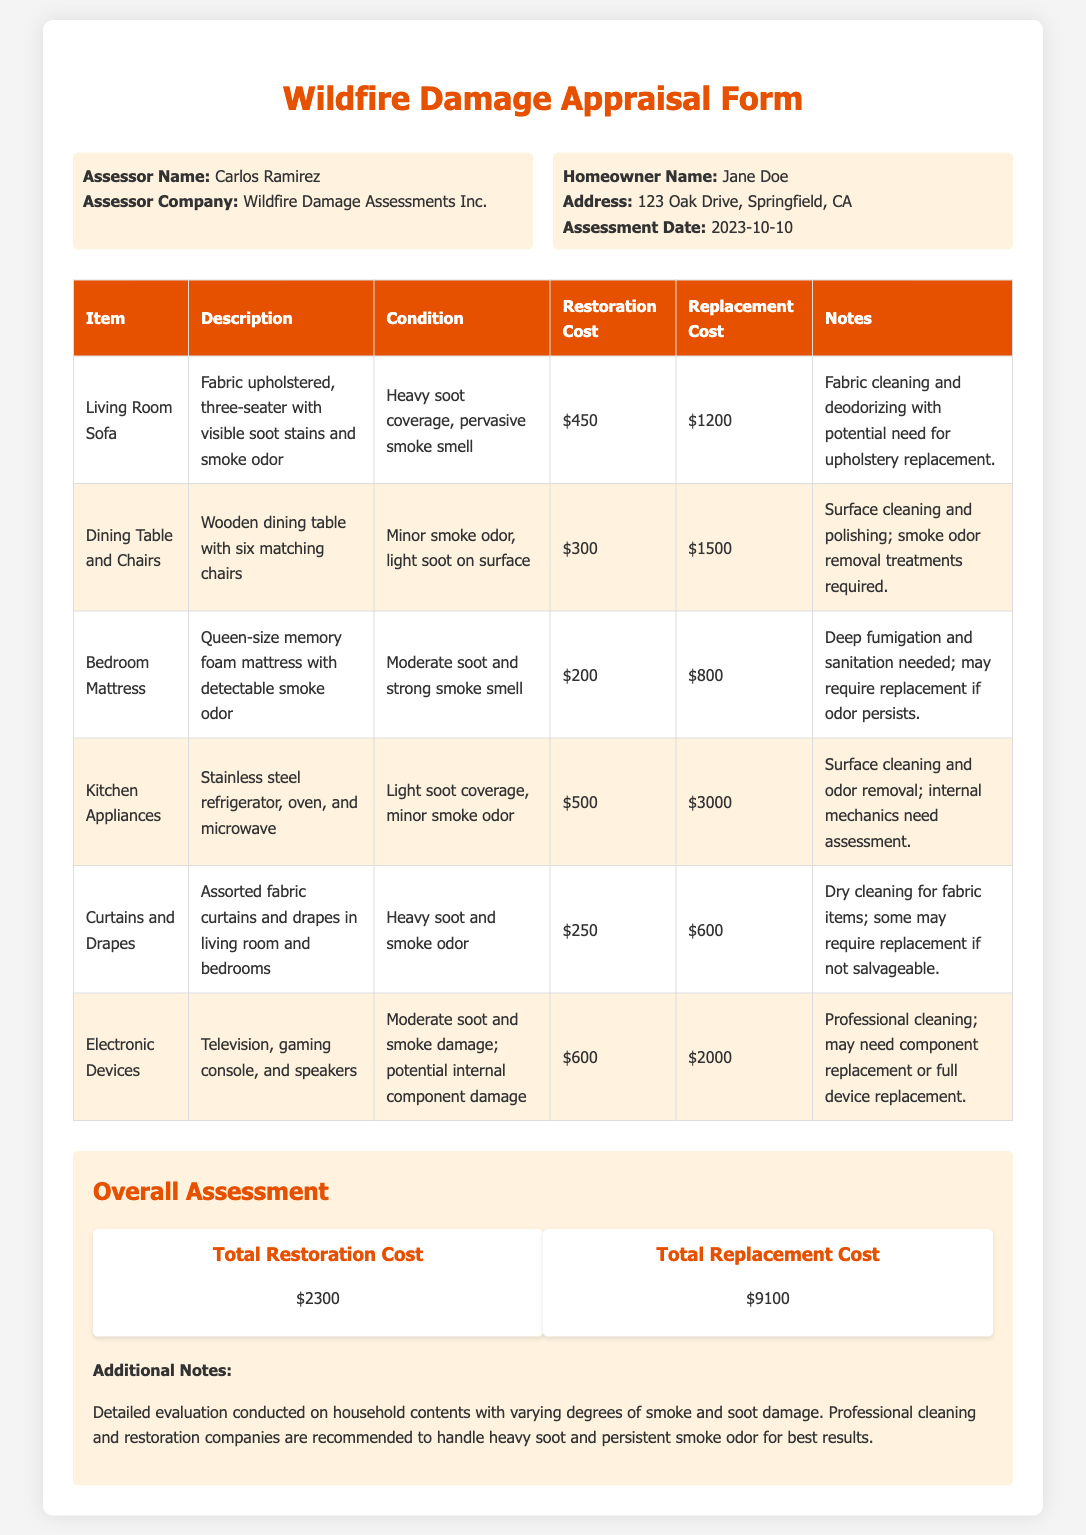what is the assessor's name? The assessor's name is listed in the personal information section of the document.
Answer: Carlos Ramirez what is the total restoration cost? The total restoration cost is summarized in the overall assessment section of the document.
Answer: $2300 what is the condition of the Living Room Sofa? The condition provides details about the damage the Living Room Sofa sustained.
Answer: Heavy soot coverage, pervasive smoke smell how much does it cost to replace the Bedroom Mattress? The replacement cost for the Bedroom Mattress is specified in the items table in the document.
Answer: $800 what is the additional note regarding the evaluation? The additional note provides insights on the evaluation process and recommendations.
Answer: Professional cleaning and restoration companies are recommended to handle heavy soot and persistent smoke odor for best results what is the homeowner's address? The address of the homeowner is provided in the personal information section.
Answer: 123 Oak Drive, Springfield, CA what cleaning method is suggested for the Curtains and Drapes? The suggested method for cleaning the Curtains and Drapes is mentioned in the item details.
Answer: Dry cleaning what are the components in the Electronics Devices damage? The document lists specific items that were damaged in the Electronics Devices category.
Answer: Television, gaming console, and speakers what is the assessment date? The date of assessment is noted in the personal information section of the document.
Answer: 2023-10-10 